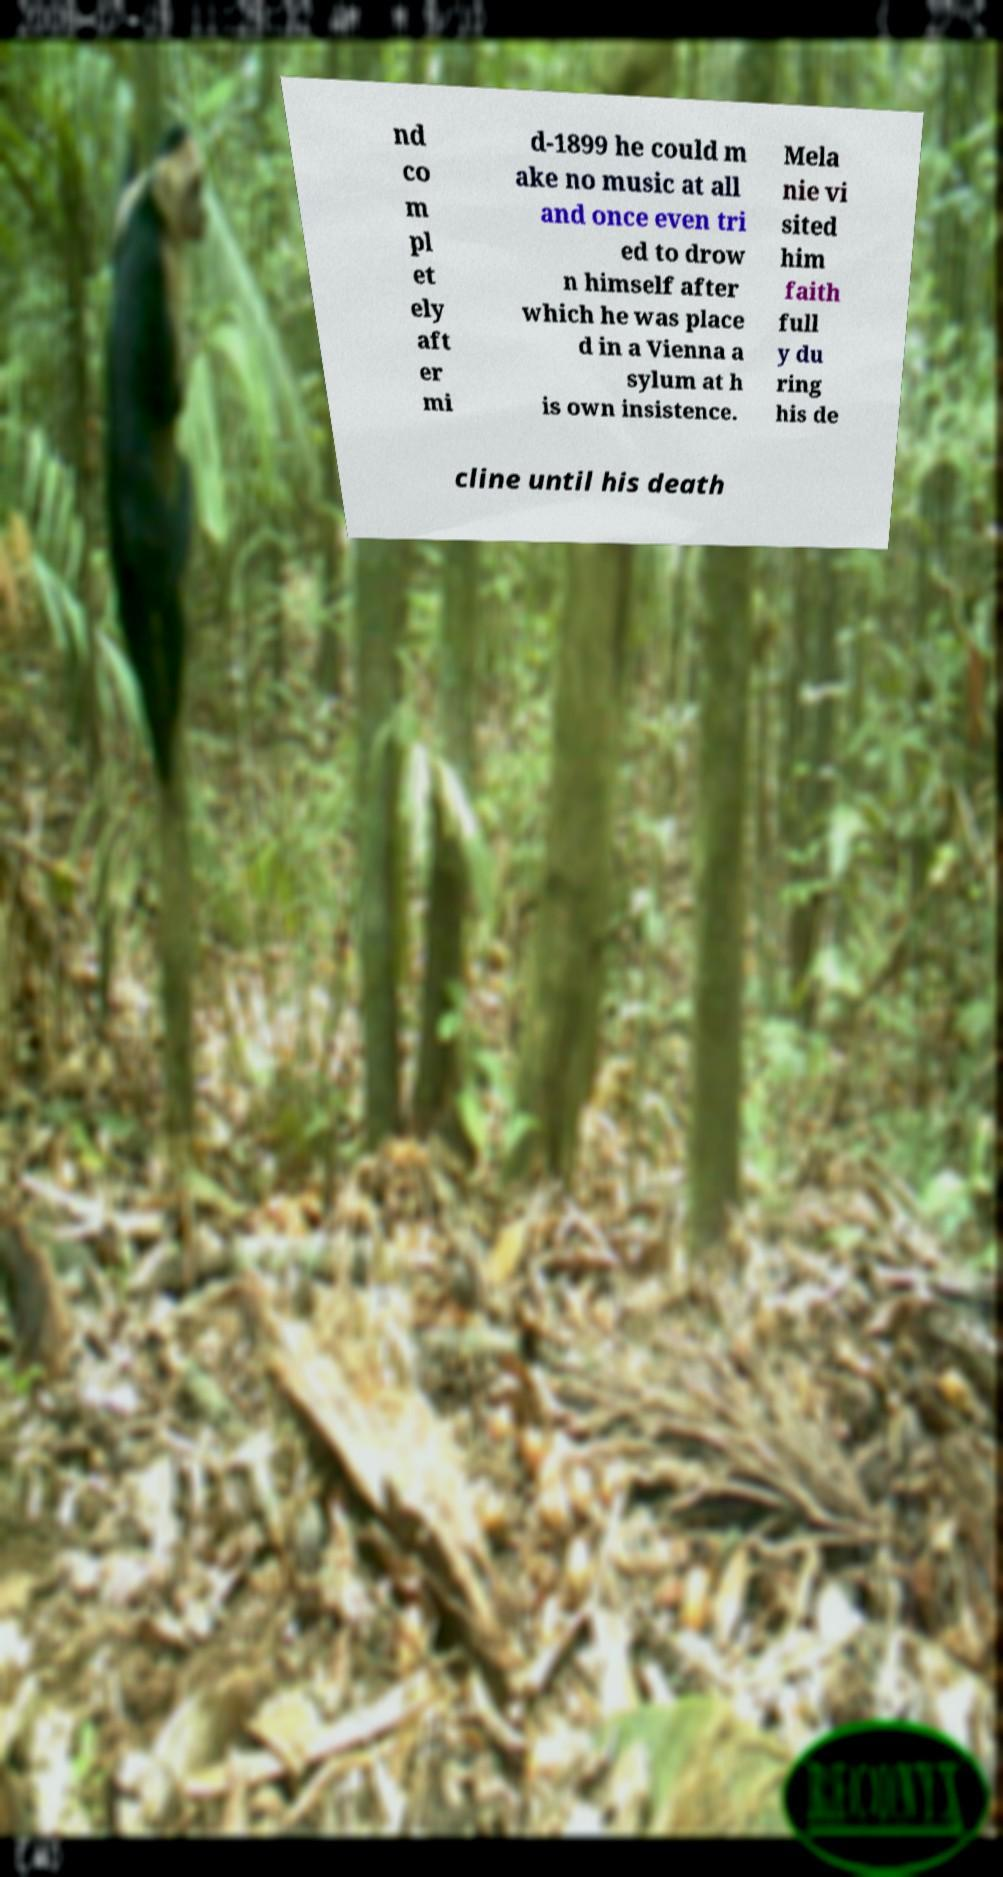For documentation purposes, I need the text within this image transcribed. Could you provide that? nd co m pl et ely aft er mi d-1899 he could m ake no music at all and once even tri ed to drow n himself after which he was place d in a Vienna a sylum at h is own insistence. Mela nie vi sited him faith full y du ring his de cline until his death 